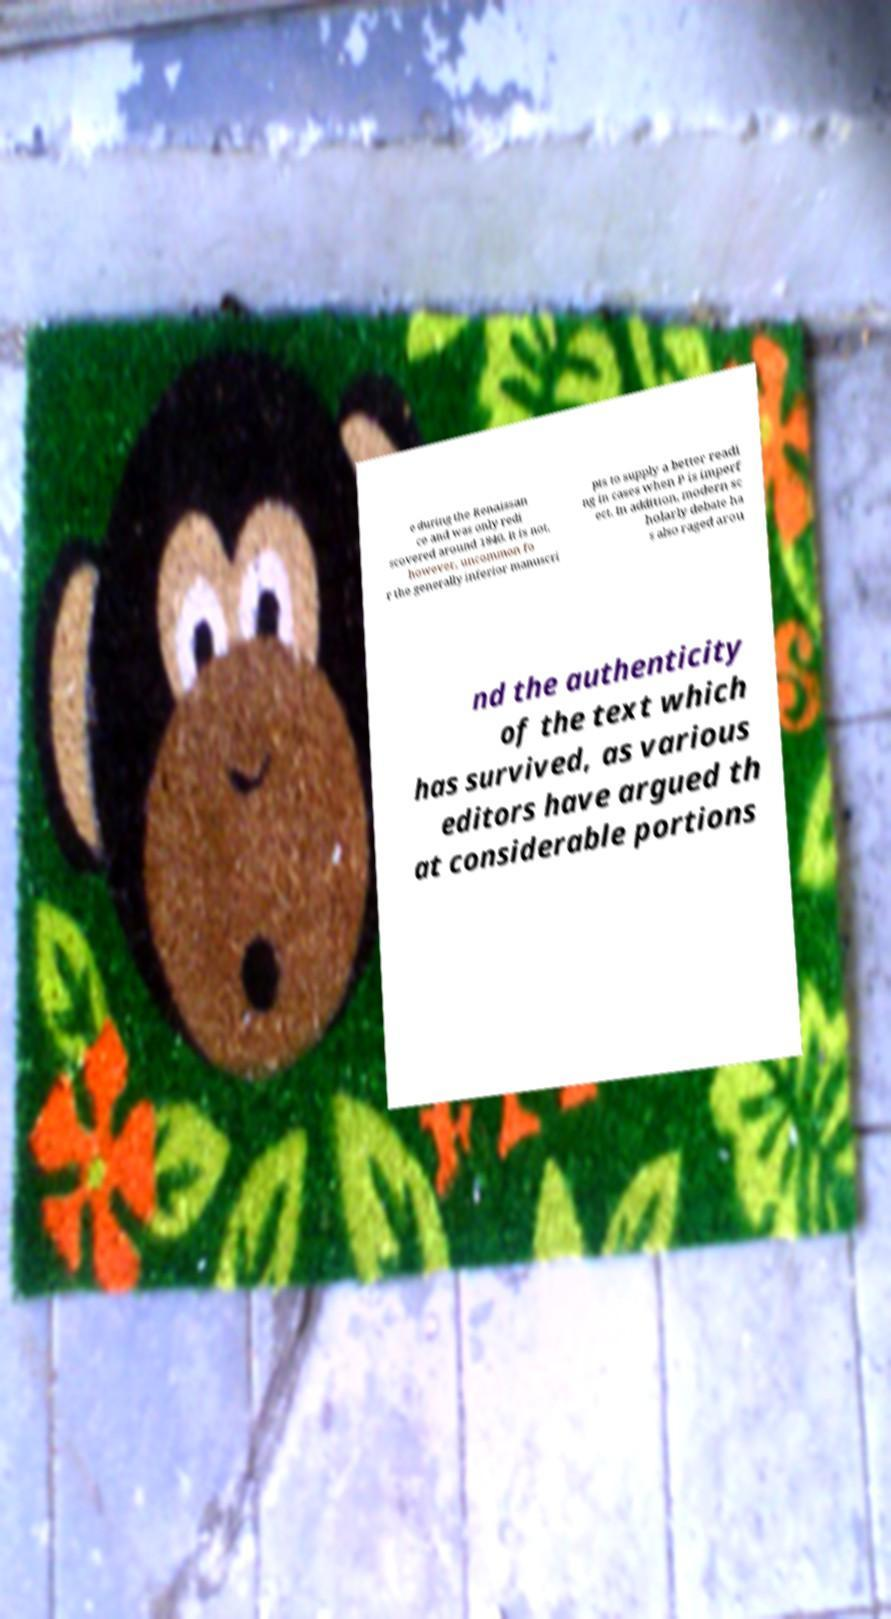Could you extract and type out the text from this image? e during the Renaissan ce and was only redi scovered around 1840. It is not, however, uncommon fo r the generally inferior manuscri pts to supply a better readi ng in cases when P is imperf ect. In addition, modern sc holarly debate ha s also raged arou nd the authenticity of the text which has survived, as various editors have argued th at considerable portions 